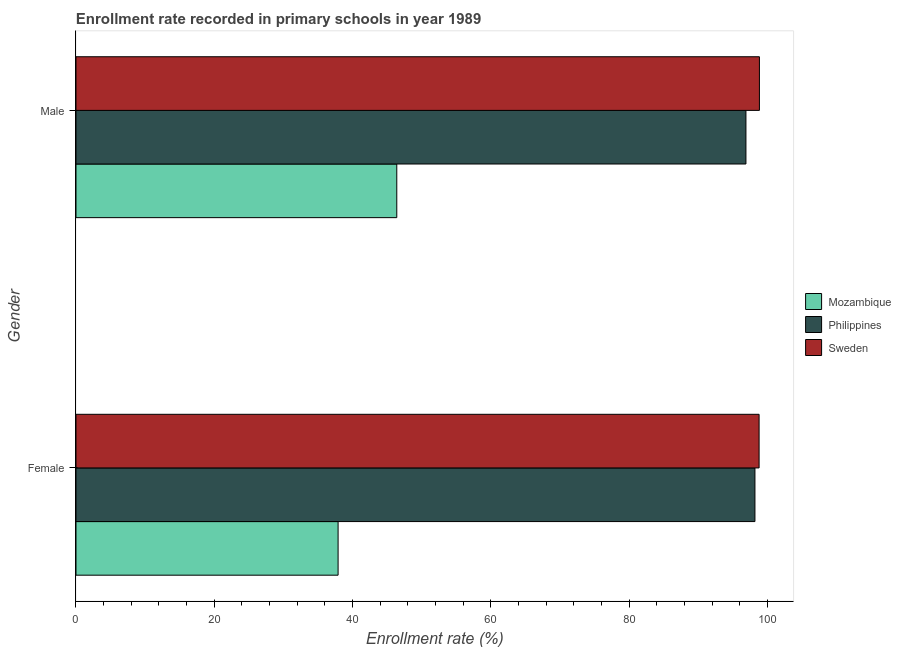How many different coloured bars are there?
Provide a succinct answer. 3. What is the enrollment rate of female students in Philippines?
Make the answer very short. 98.19. Across all countries, what is the maximum enrollment rate of male students?
Your answer should be very brief. 98.84. Across all countries, what is the minimum enrollment rate of female students?
Keep it short and to the point. 37.91. In which country was the enrollment rate of male students maximum?
Offer a terse response. Sweden. In which country was the enrollment rate of male students minimum?
Provide a short and direct response. Mozambique. What is the total enrollment rate of male students in the graph?
Provide a short and direct response. 242.12. What is the difference between the enrollment rate of female students in Philippines and that in Mozambique?
Provide a succinct answer. 60.29. What is the difference between the enrollment rate of female students in Sweden and the enrollment rate of male students in Mozambique?
Ensure brevity in your answer.  52.4. What is the average enrollment rate of female students per country?
Ensure brevity in your answer.  78.3. What is the difference between the enrollment rate of female students and enrollment rate of male students in Sweden?
Provide a short and direct response. -0.05. In how many countries, is the enrollment rate of female students greater than 24 %?
Provide a succinct answer. 3. What is the ratio of the enrollment rate of male students in Mozambique to that in Philippines?
Give a very brief answer. 0.48. What does the 2nd bar from the top in Male represents?
Offer a very short reply. Philippines. How many bars are there?
Ensure brevity in your answer.  6. Are all the bars in the graph horizontal?
Provide a short and direct response. Yes. Where does the legend appear in the graph?
Your answer should be very brief. Center right. How many legend labels are there?
Your answer should be compact. 3. What is the title of the graph?
Ensure brevity in your answer.  Enrollment rate recorded in primary schools in year 1989. What is the label or title of the X-axis?
Provide a succinct answer. Enrollment rate (%). What is the label or title of the Y-axis?
Offer a terse response. Gender. What is the Enrollment rate (%) in Mozambique in Female?
Provide a short and direct response. 37.91. What is the Enrollment rate (%) in Philippines in Female?
Your response must be concise. 98.19. What is the Enrollment rate (%) of Sweden in Female?
Provide a succinct answer. 98.79. What is the Enrollment rate (%) in Mozambique in Male?
Your answer should be compact. 46.39. What is the Enrollment rate (%) in Philippines in Male?
Keep it short and to the point. 96.89. What is the Enrollment rate (%) in Sweden in Male?
Make the answer very short. 98.84. Across all Gender, what is the maximum Enrollment rate (%) of Mozambique?
Give a very brief answer. 46.39. Across all Gender, what is the maximum Enrollment rate (%) in Philippines?
Provide a succinct answer. 98.19. Across all Gender, what is the maximum Enrollment rate (%) in Sweden?
Your answer should be compact. 98.84. Across all Gender, what is the minimum Enrollment rate (%) of Mozambique?
Your answer should be very brief. 37.91. Across all Gender, what is the minimum Enrollment rate (%) in Philippines?
Offer a terse response. 96.89. Across all Gender, what is the minimum Enrollment rate (%) of Sweden?
Make the answer very short. 98.79. What is the total Enrollment rate (%) of Mozambique in the graph?
Make the answer very short. 84.3. What is the total Enrollment rate (%) in Philippines in the graph?
Your answer should be compact. 195.08. What is the total Enrollment rate (%) of Sweden in the graph?
Make the answer very short. 197.63. What is the difference between the Enrollment rate (%) of Mozambique in Female and that in Male?
Offer a terse response. -8.49. What is the difference between the Enrollment rate (%) of Philippines in Female and that in Male?
Offer a very short reply. 1.3. What is the difference between the Enrollment rate (%) of Sweden in Female and that in Male?
Provide a succinct answer. -0.05. What is the difference between the Enrollment rate (%) in Mozambique in Female and the Enrollment rate (%) in Philippines in Male?
Your answer should be compact. -58.98. What is the difference between the Enrollment rate (%) in Mozambique in Female and the Enrollment rate (%) in Sweden in Male?
Your response must be concise. -60.93. What is the difference between the Enrollment rate (%) in Philippines in Female and the Enrollment rate (%) in Sweden in Male?
Your answer should be compact. -0.65. What is the average Enrollment rate (%) in Mozambique per Gender?
Ensure brevity in your answer.  42.15. What is the average Enrollment rate (%) of Philippines per Gender?
Keep it short and to the point. 97.54. What is the average Enrollment rate (%) of Sweden per Gender?
Offer a very short reply. 98.82. What is the difference between the Enrollment rate (%) of Mozambique and Enrollment rate (%) of Philippines in Female?
Offer a very short reply. -60.29. What is the difference between the Enrollment rate (%) of Mozambique and Enrollment rate (%) of Sweden in Female?
Offer a terse response. -60.89. What is the difference between the Enrollment rate (%) in Philippines and Enrollment rate (%) in Sweden in Female?
Give a very brief answer. -0.6. What is the difference between the Enrollment rate (%) of Mozambique and Enrollment rate (%) of Philippines in Male?
Make the answer very short. -50.5. What is the difference between the Enrollment rate (%) in Mozambique and Enrollment rate (%) in Sweden in Male?
Offer a terse response. -52.44. What is the difference between the Enrollment rate (%) in Philippines and Enrollment rate (%) in Sweden in Male?
Your response must be concise. -1.95. What is the ratio of the Enrollment rate (%) of Mozambique in Female to that in Male?
Ensure brevity in your answer.  0.82. What is the ratio of the Enrollment rate (%) in Philippines in Female to that in Male?
Offer a very short reply. 1.01. What is the difference between the highest and the second highest Enrollment rate (%) in Mozambique?
Provide a succinct answer. 8.49. What is the difference between the highest and the second highest Enrollment rate (%) of Philippines?
Keep it short and to the point. 1.3. What is the difference between the highest and the second highest Enrollment rate (%) in Sweden?
Ensure brevity in your answer.  0.05. What is the difference between the highest and the lowest Enrollment rate (%) of Mozambique?
Provide a succinct answer. 8.49. What is the difference between the highest and the lowest Enrollment rate (%) in Philippines?
Make the answer very short. 1.3. What is the difference between the highest and the lowest Enrollment rate (%) of Sweden?
Make the answer very short. 0.05. 